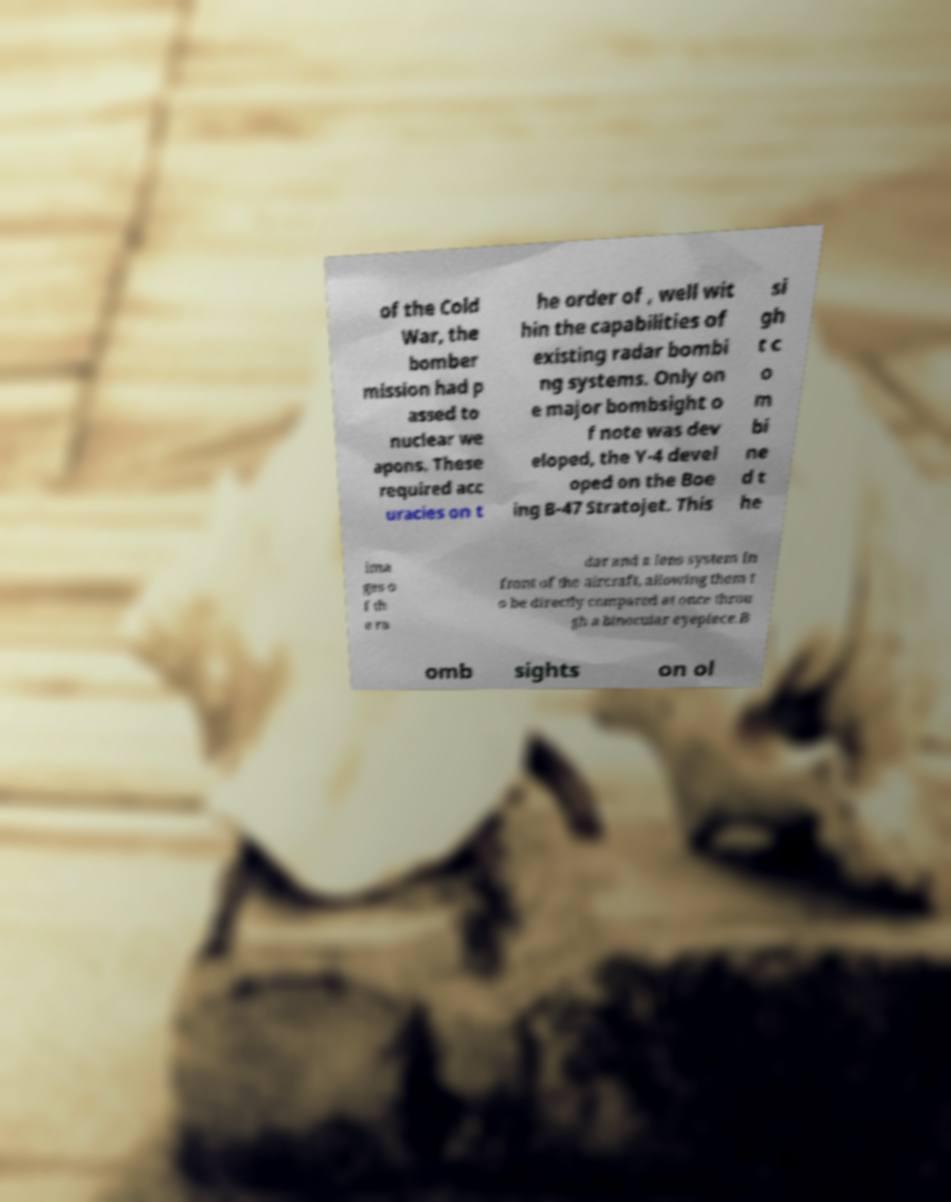Could you assist in decoding the text presented in this image and type it out clearly? of the Cold War, the bomber mission had p assed to nuclear we apons. These required acc uracies on t he order of , well wit hin the capabilities of existing radar bombi ng systems. Only on e major bombsight o f note was dev eloped, the Y-4 devel oped on the Boe ing B-47 Stratojet. This si gh t c o m bi ne d t he ima ges o f th e ra dar and a lens system in front of the aircraft, allowing them t o be directly compared at once throu gh a binocular eyepiece.B omb sights on ol 